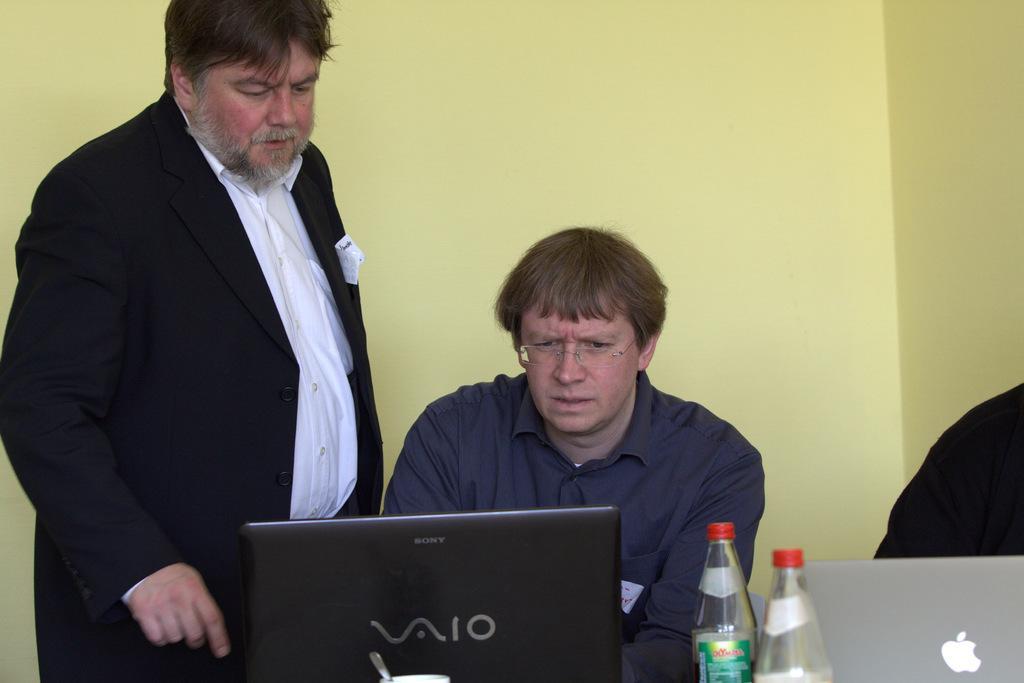In one or two sentences, can you explain what this image depicts? In this image, there are two persons. One is standing who's wearing a black color suit and another is sitting in front of the laptop. In the right side of the image bottom, person is visible which is half and a Apple laptop is visible and two bottles are visible. In the background a wall is visible which is light yellow in color. This image is taken inside the office. 